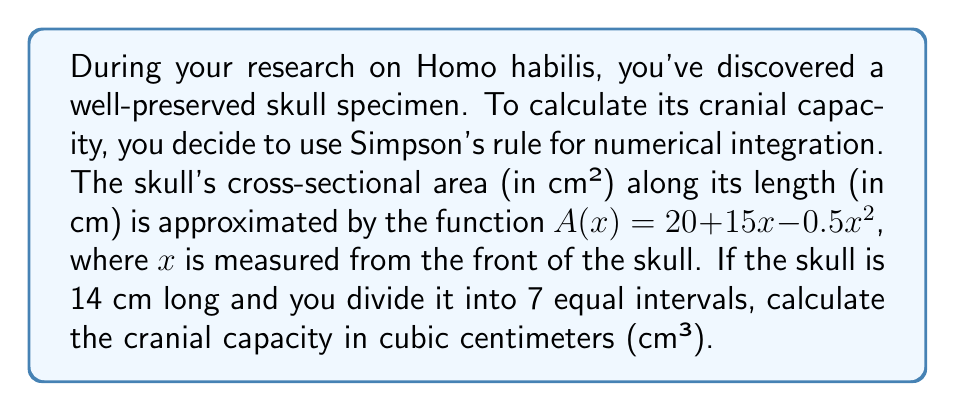Teach me how to tackle this problem. To solve this problem, we'll use Simpson's rule for numerical integration:

1) Simpson's rule formula:
   $$\int_{a}^{b} f(x)dx \approx \frac{h}{3}[f(x_0) + 4f(x_1) + 2f(x_2) + 4f(x_3) + 2f(x_4) + 4f(x_5) + f(x_6)]$$
   where $h = \frac{b-a}{n}$, and $n$ is the number of intervals (must be even).

2) Given information:
   - Length of skull: $14$ cm
   - Number of intervals: $7$
   - $A(x) = 20 + 15x - 0.5x^2$

3) Calculate $h$:
   $h = \frac{14}{7} = 2$ cm

4) Calculate $x$ values:
   $x_0 = 0$, $x_1 = 2$, $x_2 = 4$, $x_3 = 6$, $x_4 = 8$, $x_5 = 10$, $x_6 = 12$, $x_7 = 14$

5) Calculate $A(x)$ for each $x$ value:
   $A(0) = 20$
   $A(2) = 20 + 30 - 2 = 48$
   $A(4) = 20 + 60 - 8 = 72$
   $A(6) = 20 + 90 - 18 = 92$
   $A(8) = 20 + 120 - 32 = 108$
   $A(10) = 20 + 150 - 50 = 120$
   $A(12) = 20 + 180 - 72 = 128$
   $A(14) = 20 + 210 - 98 = 132$

6) Apply Simpson's rule:
   $$V \approx \frac{2}{3}[20 + 4(48) + 2(72) + 4(92) + 2(108) + 4(120) + 128]$$
   $$V \approx \frac{2}{3}[20 + 192 + 144 + 368 + 216 + 480 + 128]$$
   $$V \approx \frac{2}{3}[1548] = 1032$$

Therefore, the cranial capacity is approximately 1032 cm³.
Answer: 1032 cm³ 